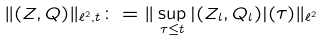<formula> <loc_0><loc_0><loc_500><loc_500>\| ( Z , Q ) \| _ { \ell ^ { 2 } , t } \colon = \| \sup _ { \tau \leq t } | ( Z _ { l } , Q _ { l } ) | ( \tau ) \| _ { \ell ^ { 2 } }</formula> 